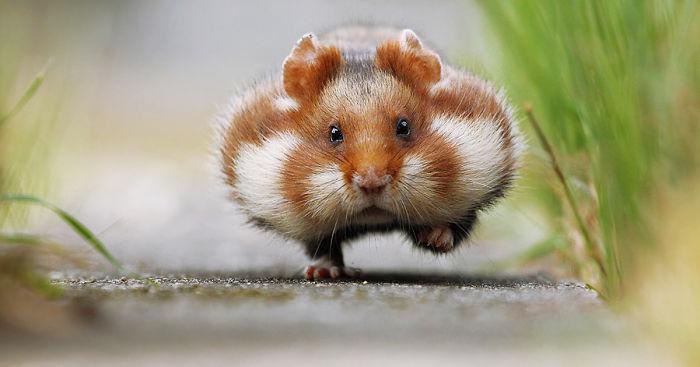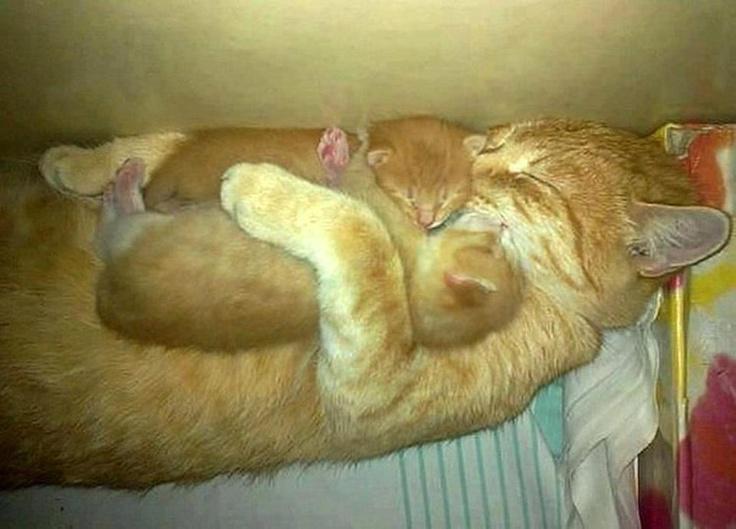The first image is the image on the left, the second image is the image on the right. Assess this claim about the two images: "a hamster is sitting atop draped fabric". Correct or not? Answer yes or no. No. The first image is the image on the left, the second image is the image on the right. Assess this claim about the two images: "There are exactly two animals.". Correct or not? Answer yes or no. No. 